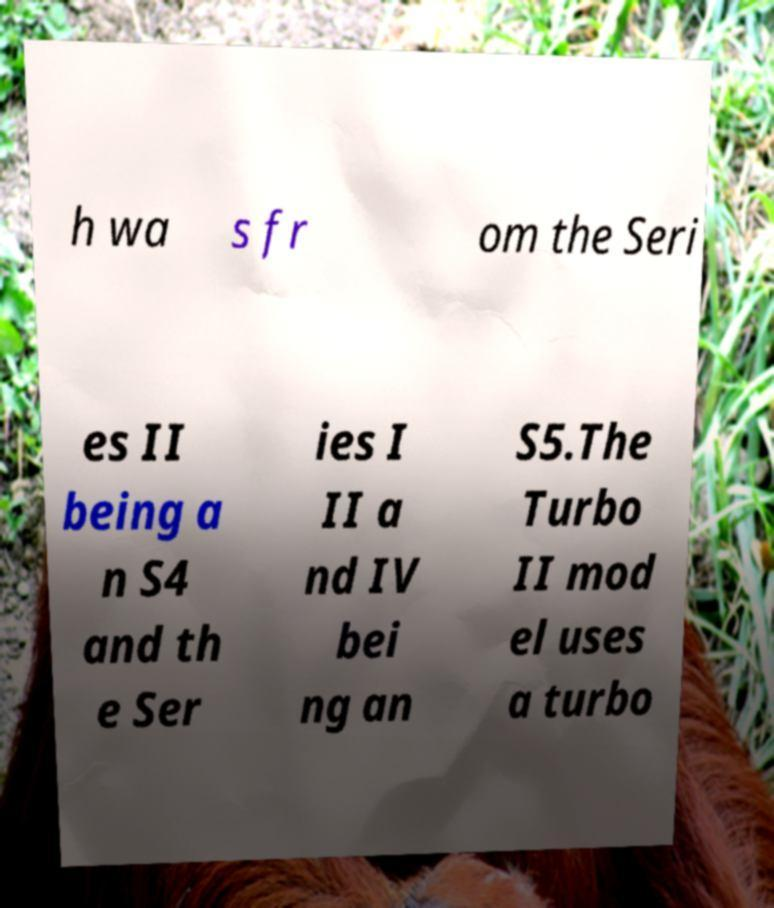Could you extract and type out the text from this image? h wa s fr om the Seri es II being a n S4 and th e Ser ies I II a nd IV bei ng an S5.The Turbo II mod el uses a turbo 